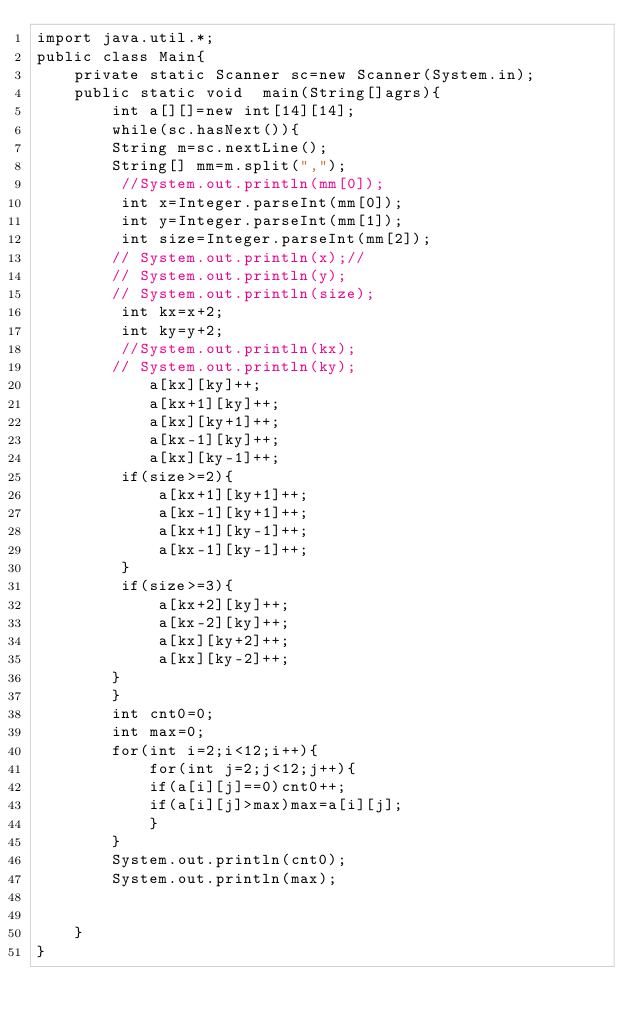Convert code to text. <code><loc_0><loc_0><loc_500><loc_500><_Java_>import java.util.*;
public class Main{
	private static Scanner sc=new Scanner(System.in);
	public static void  main(String[]agrs){
		int a[][]=new int[14][14];
		while(sc.hasNext()){
		String m=sc.nextLine();
		String[] mm=m.split(",");
		 //System.out.println(mm[0]);
		 int x=Integer.parseInt(mm[0]);
		 int y=Integer.parseInt(mm[1]);
		 int size=Integer.parseInt(mm[2]);
		// System.out.println(x);//
		// System.out.println(y);
		// System.out.println(size);
		 int kx=x+2;
		 int ky=y+2;
		 //System.out.println(kx);
		// System.out.println(ky);
			a[kx][ky]++;
			a[kx+1][ky]++;
			a[kx][ky+1]++;
			a[kx-1][ky]++;
			a[kx][ky-1]++;
		 if(size>=2){
			 a[kx+1][ky+1]++;
			 a[kx-1][ky+1]++;
			 a[kx+1][ky-1]++;
			 a[kx-1][ky-1]++;
		 }
		 if(size>=3){
			 a[kx+2][ky]++;
			 a[kx-2][ky]++;
			 a[kx][ky+2]++;
			 a[kx][ky-2]++;
		}
		}
		int cnt0=0;
		int max=0;
		for(int i=2;i<12;i++){
			for(int j=2;j<12;j++){
			if(a[i][j]==0)cnt0++;
			if(a[i][j]>max)max=a[i][j];
			}
		}
		System.out.println(cnt0);
		System.out.println(max);
		
	
	}
}</code> 